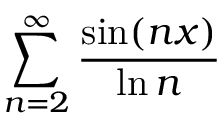<formula> <loc_0><loc_0><loc_500><loc_500>\sum _ { n = 2 } ^ { \infty } { \frac { \sin ( n x ) } { \ln n } }</formula> 